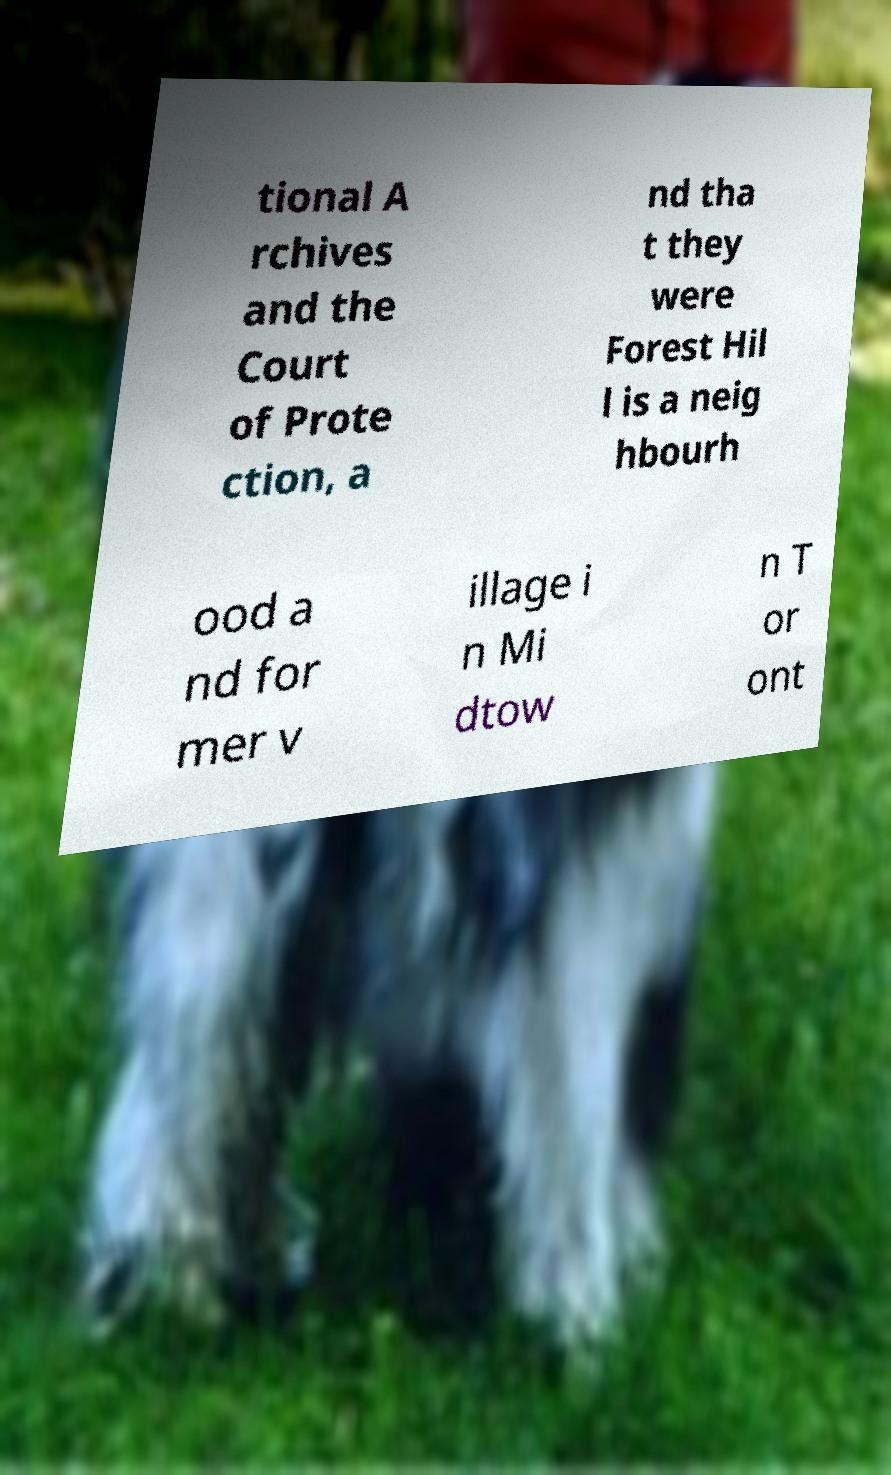I need the written content from this picture converted into text. Can you do that? tional A rchives and the Court of Prote ction, a nd tha t they were Forest Hil l is a neig hbourh ood a nd for mer v illage i n Mi dtow n T or ont 